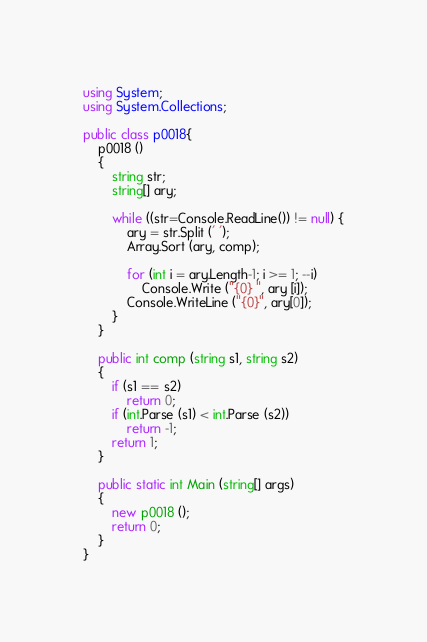<code> <loc_0><loc_0><loc_500><loc_500><_C#_>using System;
using System.Collections;

public class p0018{
	p0018 ()
	{
		string str;
		string[] ary;
		
		while ((str=Console.ReadLine()) != null) {
			ary = str.Split (' ');
			Array.Sort (ary, comp);
			
			for (int i = ary.Length-1; i >= 1; --i)
				Console.Write ("{0} ", ary [i]);
			Console.WriteLine ("{0}", ary[0]);
		}
	}
	
	public int comp (string s1, string s2)
	{
		if (s1 == s2)
			return 0;
		if (int.Parse (s1) < int.Parse (s2))
			return -1;
		return 1;
	}
	
	public static int Main (string[] args)
	{
		new p0018 ();
		return 0;
	}
}</code> 